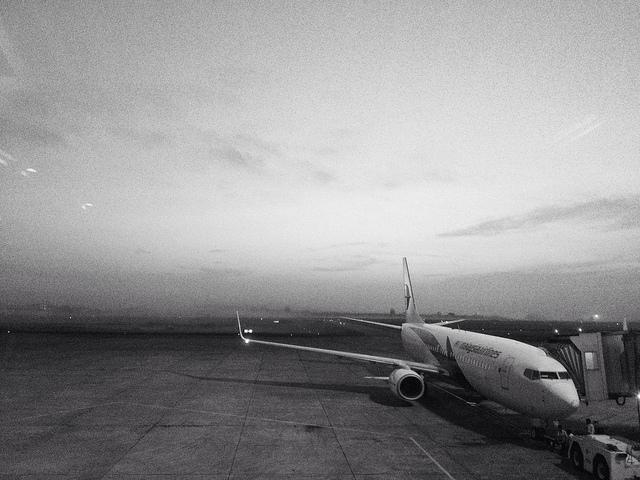What time is it on the image? night 